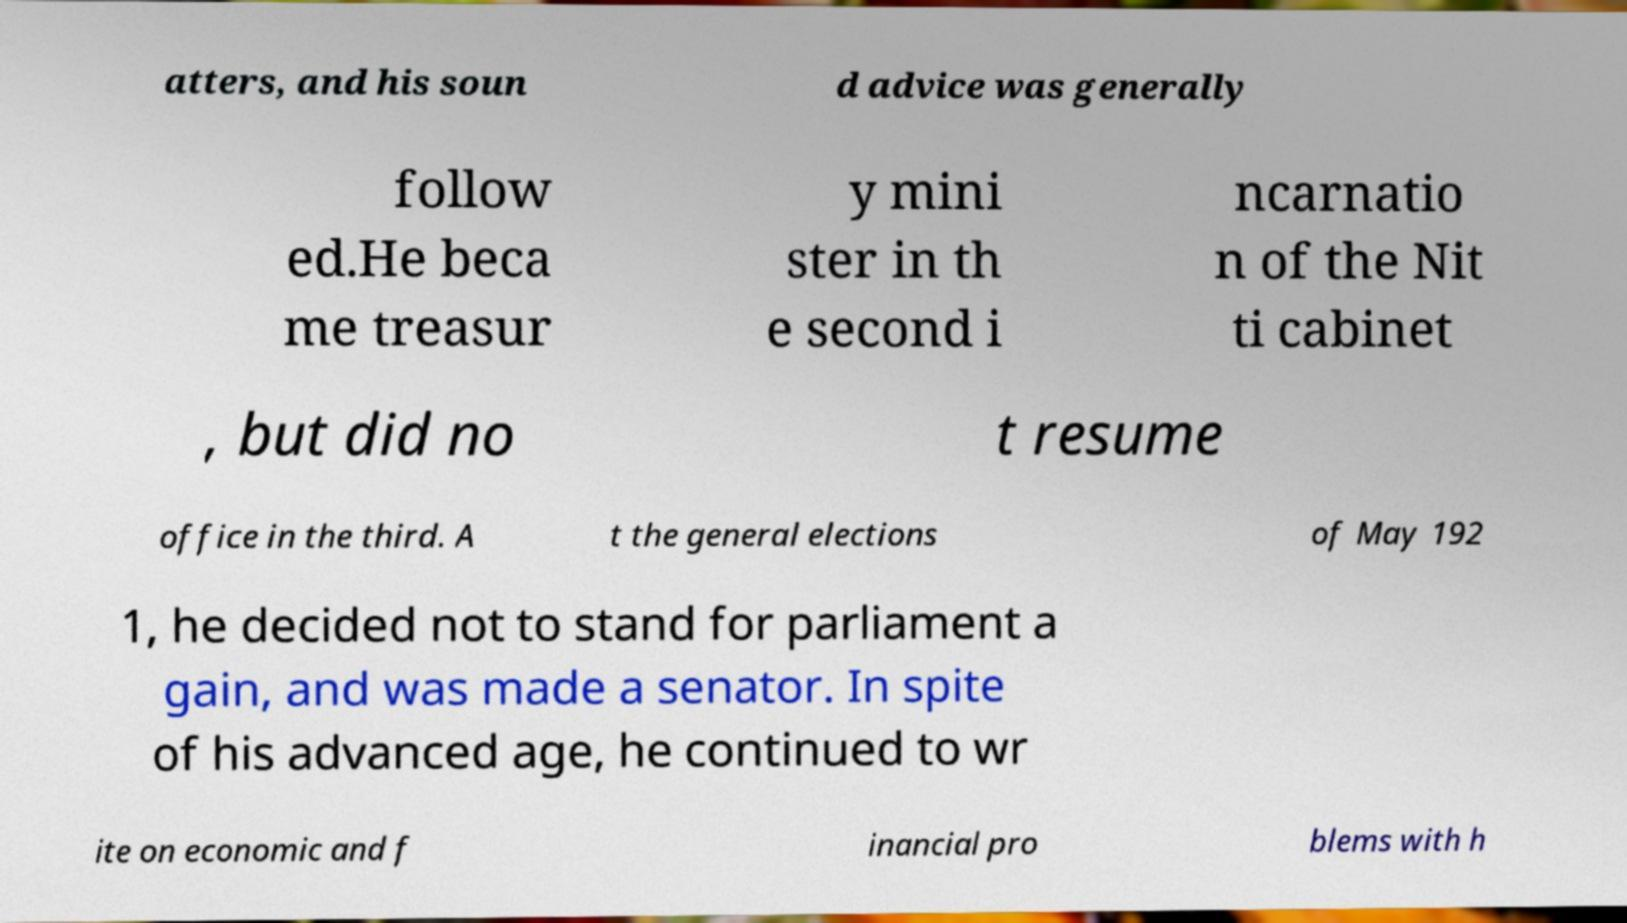Can you read and provide the text displayed in the image?This photo seems to have some interesting text. Can you extract and type it out for me? atters, and his soun d advice was generally follow ed.He beca me treasur y mini ster in th e second i ncarnatio n of the Nit ti cabinet , but did no t resume office in the third. A t the general elections of May 192 1, he decided not to stand for parliament a gain, and was made a senator. In spite of his advanced age, he continued to wr ite on economic and f inancial pro blems with h 